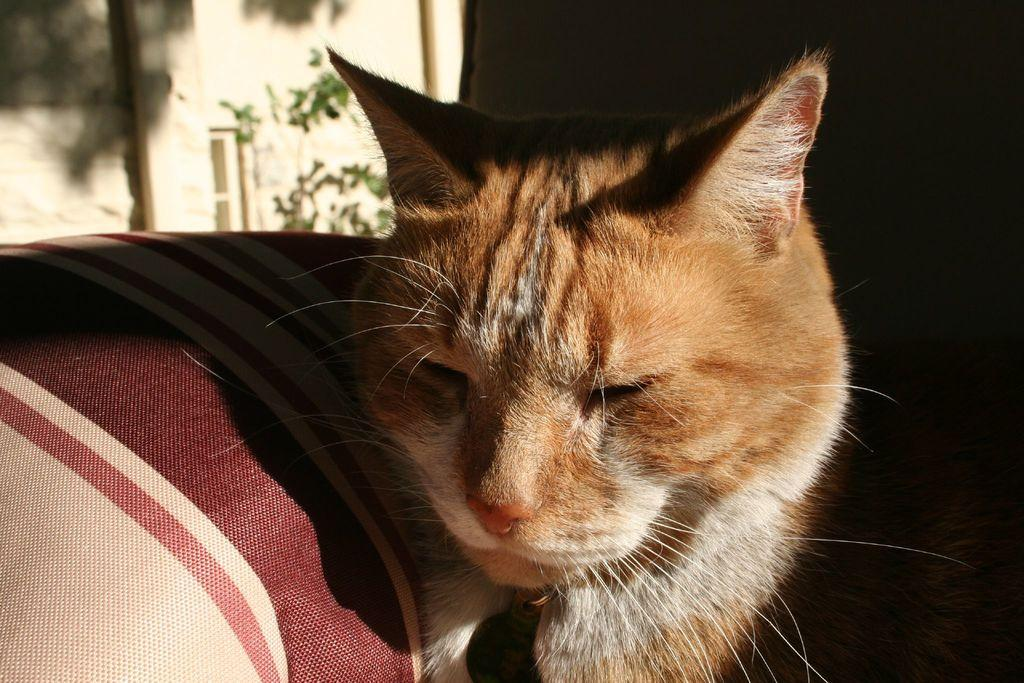What type of animal is in the image? There is a cat in the image. What is located on the left side of the image? There is a cloth on the left side of the image. What can be seen in the background of the image? There is a tree, a pole, and a wall in the background of the image. What type of shade does the cat prefer in the image? There is no information about the cat's shade preference in the image. What hobbies does the cat have in the image? There is no information about the cat's hobbies in the image. 